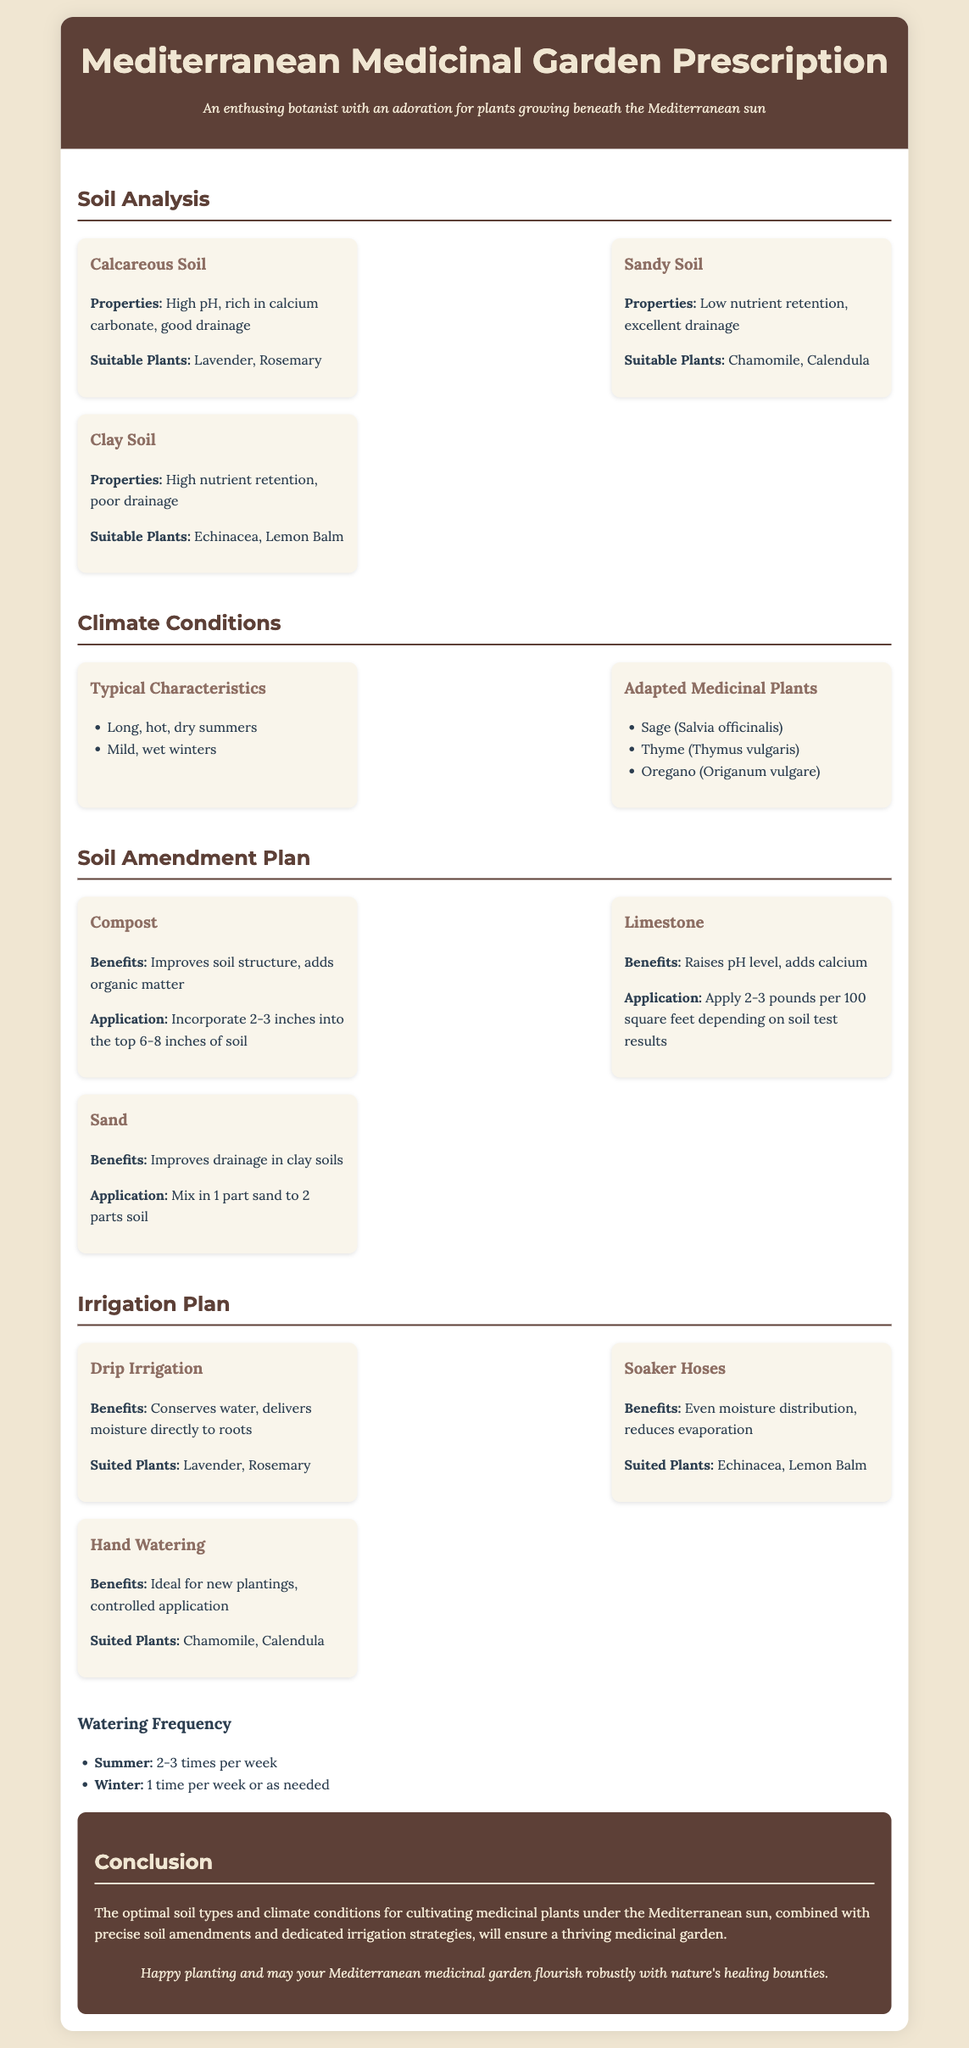What are the three soil types mentioned? The document lists three soil types: Calcareous Soil, Sandy Soil, and Clay Soil.
Answer: Calcareous Soil, Sandy Soil, Clay Soil What are the typical summer characteristics of the climate? The document states that the typical characteristics include long, hot, dry summers.
Answer: Long, hot, dry summers Which irrigation method is suited for Lavender and Rosemary? According to the document, Drip Irrigation is best suited for these plants.
Answer: Drip Irrigation What is the application method for Compost? The document instructs to incorporate 2-3 inches of compost into the top 6-8 inches of soil.
Answer: Incorporate 2-3 inches into the top 6-8 inches of soil How frequently should plants be watered in summer? The document specifies that plants should be watered 2-3 times per week during summer.
Answer: 2-3 times per week What is the benefit of using Limestone? The document highlights that Limestone raises pH level and adds calcium to the soil.
Answer: Raises pH level, adds calcium How many types of amendments are listed in the soil amendment plan? The document outlines three types of soil amendments: Compost, Limestone, and Sand.
Answer: Three types Name one adapted medicinal plant mentioned in the climate conditions section. The document lists Sage (Salvia officinalis) as one of the adapted medicinal plants.
Answer: Sage (Salvia officinalis) What is one benefit of using Soaker Hoses? The document specifies that Soaker Hoses provide even moisture distribution and reduce evaporation.
Answer: Even moisture distribution, reduces evaporation 